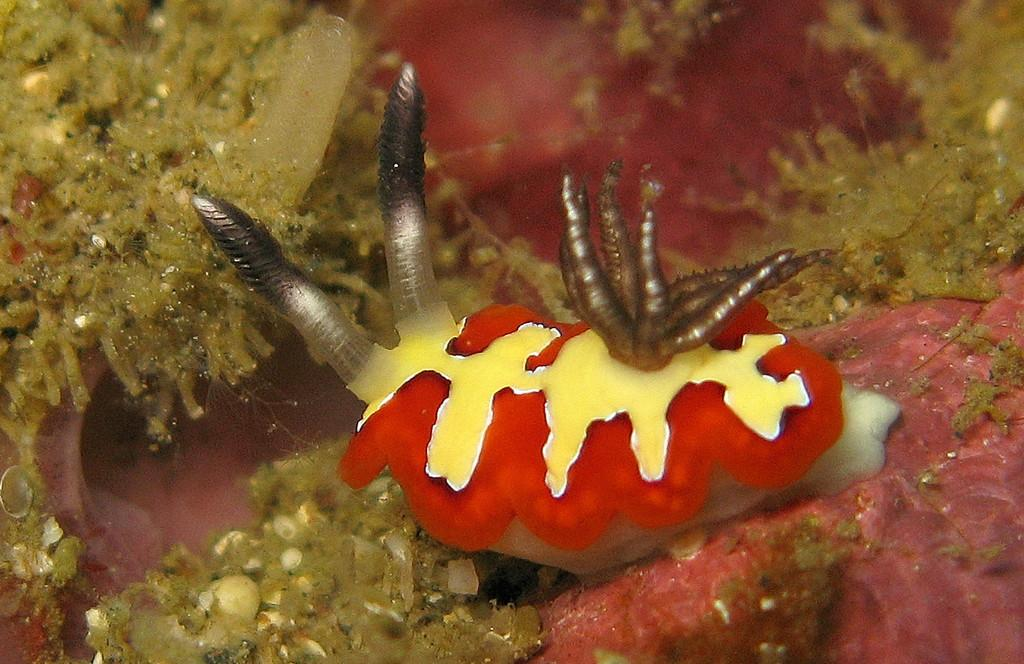What type of creature is in the image? There is an insect in the image. Where is the insect located? The insect is in water. What can be inferred about the setting of the image? The image is an underwater image. What other types of organisms can be seen in the image? There are aquatic plants present in the image. What year is depicted in the image? The image does not depict a specific year; it is a photograph of an underwater scene. How many cats are visible in the image? There are no cats present in the image; it features an underwater scene with an insect and aquatic plants. 